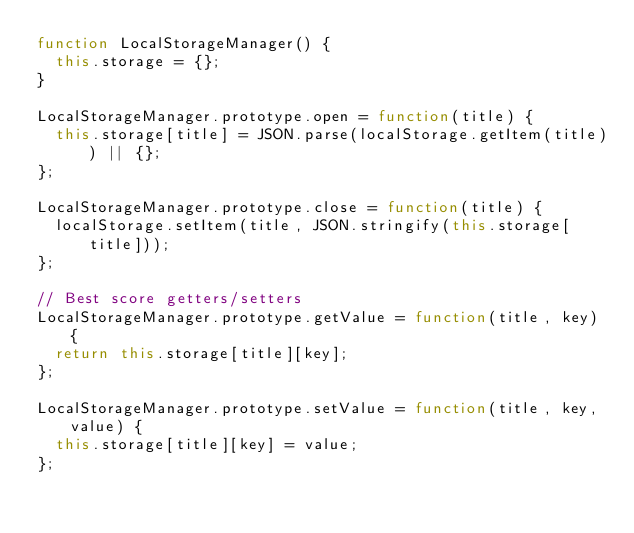<code> <loc_0><loc_0><loc_500><loc_500><_JavaScript_>function LocalStorageManager() {
  this.storage = {};
}

LocalStorageManager.prototype.open = function(title) {
  this.storage[title] = JSON.parse(localStorage.getItem(title)) || {};
};

LocalStorageManager.prototype.close = function(title) {
  localStorage.setItem(title, JSON.stringify(this.storage[title]));
};

// Best score getters/setters
LocalStorageManager.prototype.getValue = function(title, key) {
  return this.storage[title][key];
};

LocalStorageManager.prototype.setValue = function(title, key, value) {
  this.storage[title][key] = value;
};
</code> 